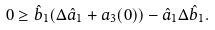<formula> <loc_0><loc_0><loc_500><loc_500>0 \geq \hat { b } _ { 1 } ( \Delta \hat { a } _ { 1 } + a _ { 3 } ( 0 ) ) - \hat { a } _ { 1 } \Delta \hat { b } _ { 1 } .</formula> 